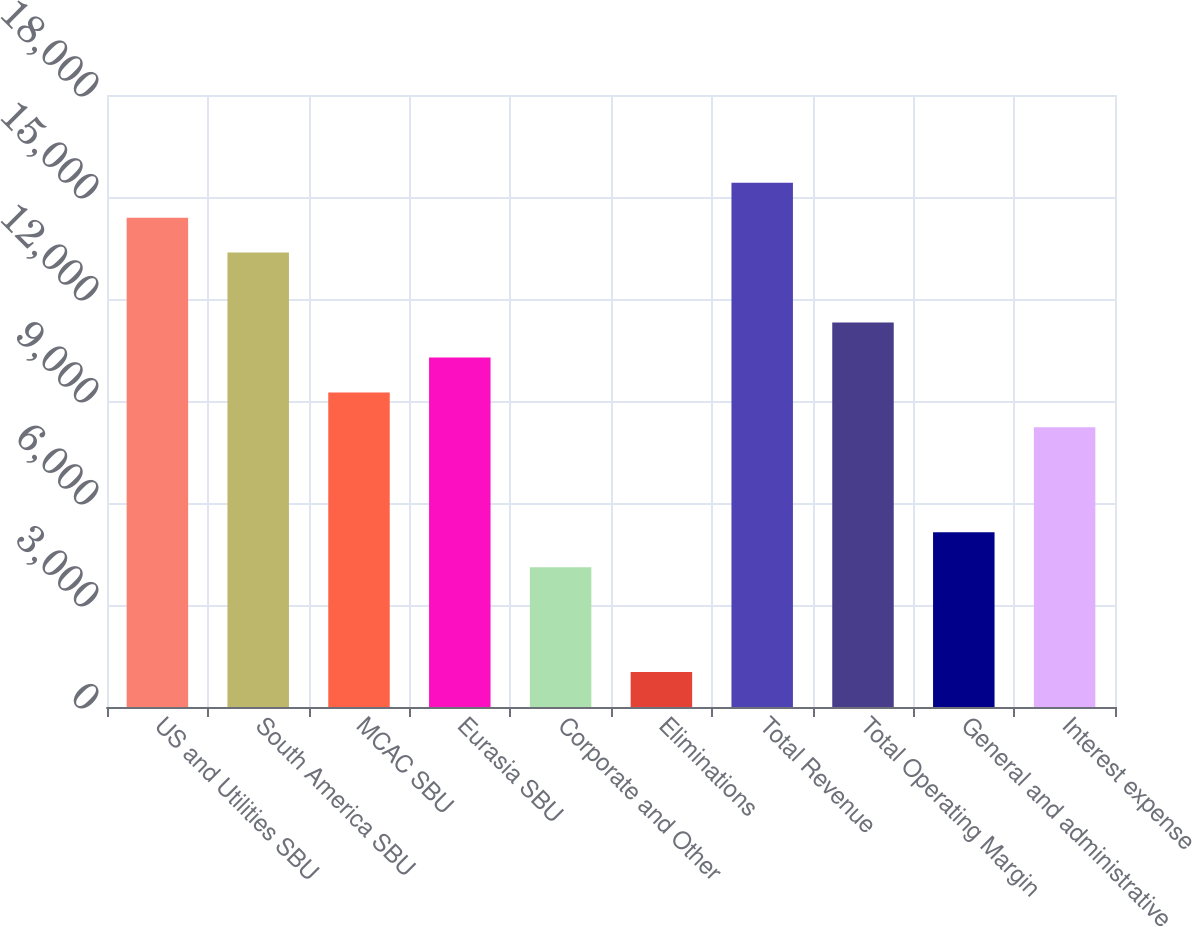Convert chart to OTSL. <chart><loc_0><loc_0><loc_500><loc_500><bar_chart><fcel>US and Utilities SBU<fcel>South America SBU<fcel>MCAC SBU<fcel>Eurasia SBU<fcel>Corporate and Other<fcel>Eliminations<fcel>Total Revenue<fcel>Total Operating Margin<fcel>General and administrative<fcel>Interest expense<nl><fcel>14393.2<fcel>13365.2<fcel>9252.97<fcel>10281<fcel>4112.68<fcel>1028.51<fcel>15421.3<fcel>11309.1<fcel>5140.74<fcel>8224.91<nl></chart> 